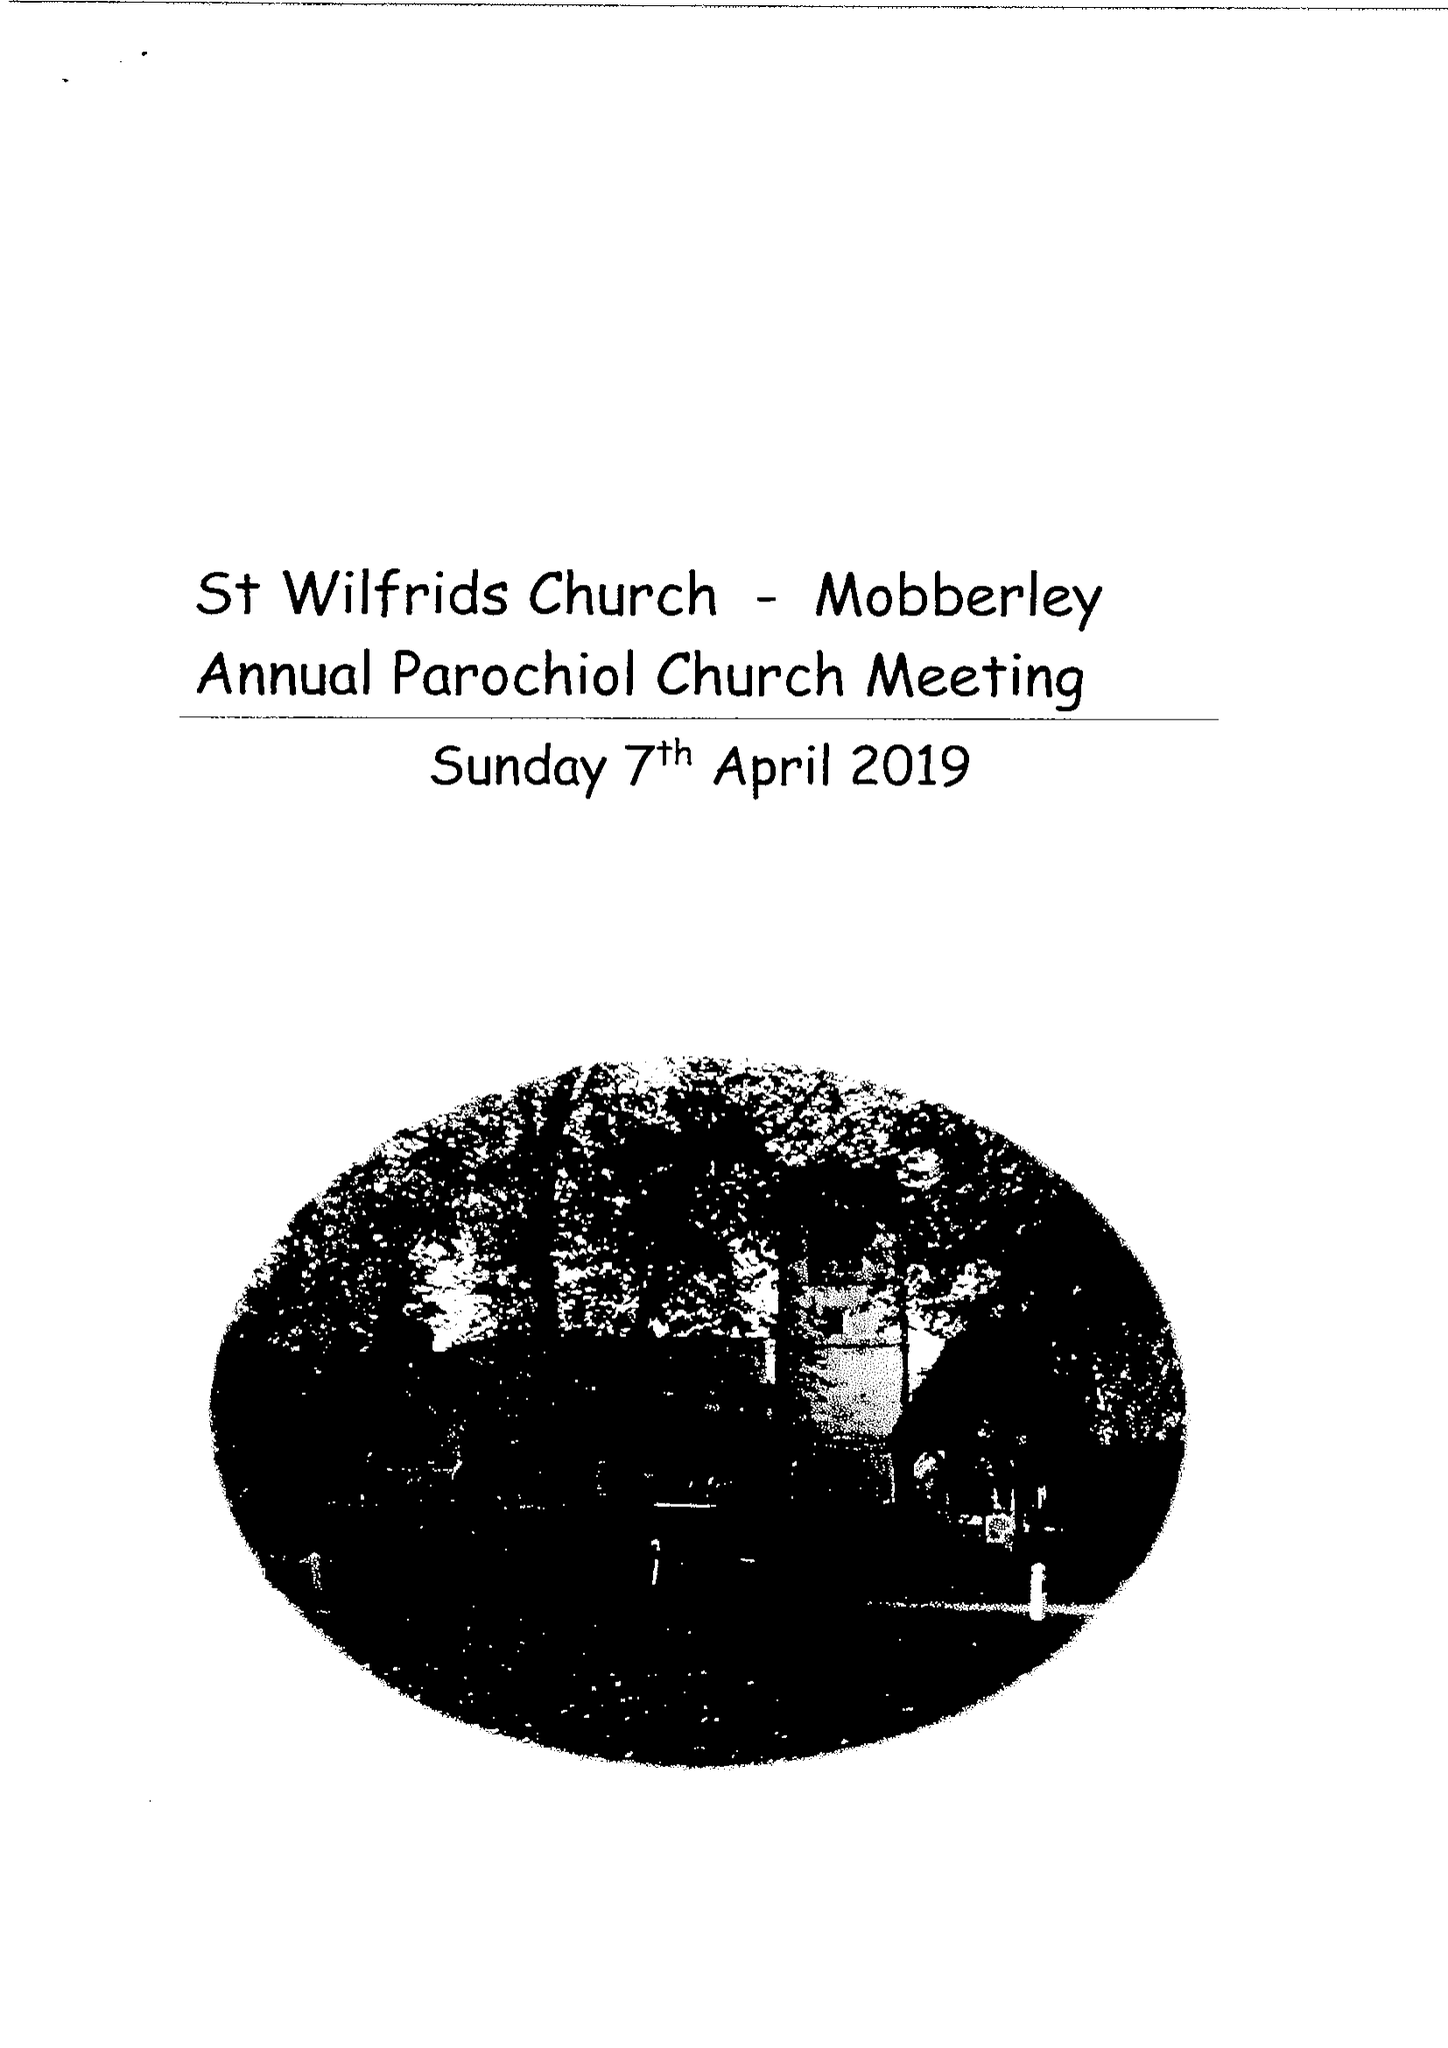What is the value for the spending_annually_in_british_pounds?
Answer the question using a single word or phrase. 143424.53 